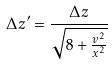Convert formula to latex. <formula><loc_0><loc_0><loc_500><loc_500>\Delta z ^ { \prime } = \frac { \Delta z } { \sqrt { 8 + \frac { v ^ { 2 } } { x ^ { 2 } } } }</formula> 